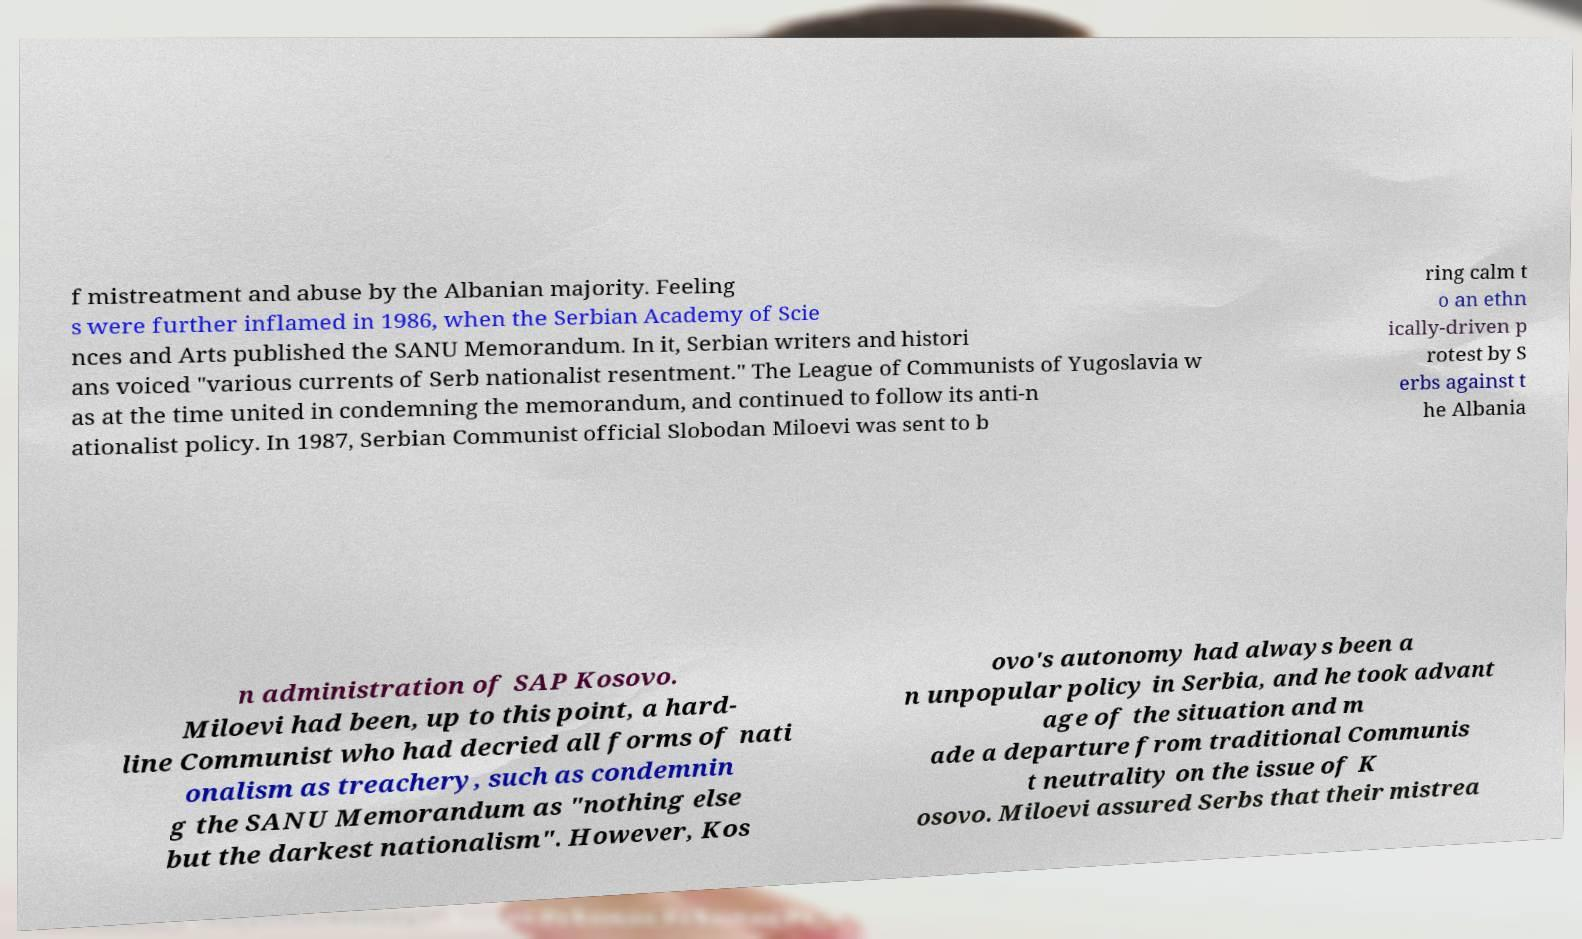For documentation purposes, I need the text within this image transcribed. Could you provide that? f mistreatment and abuse by the Albanian majority. Feeling s were further inflamed in 1986, when the Serbian Academy of Scie nces and Arts published the SANU Memorandum. In it, Serbian writers and histori ans voiced "various currents of Serb nationalist resentment." The League of Communists of Yugoslavia w as at the time united in condemning the memorandum, and continued to follow its anti-n ationalist policy. In 1987, Serbian Communist official Slobodan Miloevi was sent to b ring calm t o an ethn ically-driven p rotest by S erbs against t he Albania n administration of SAP Kosovo. Miloevi had been, up to this point, a hard- line Communist who had decried all forms of nati onalism as treachery, such as condemnin g the SANU Memorandum as "nothing else but the darkest nationalism". However, Kos ovo's autonomy had always been a n unpopular policy in Serbia, and he took advant age of the situation and m ade a departure from traditional Communis t neutrality on the issue of K osovo. Miloevi assured Serbs that their mistrea 